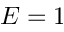Convert formula to latex. <formula><loc_0><loc_0><loc_500><loc_500>E = 1</formula> 